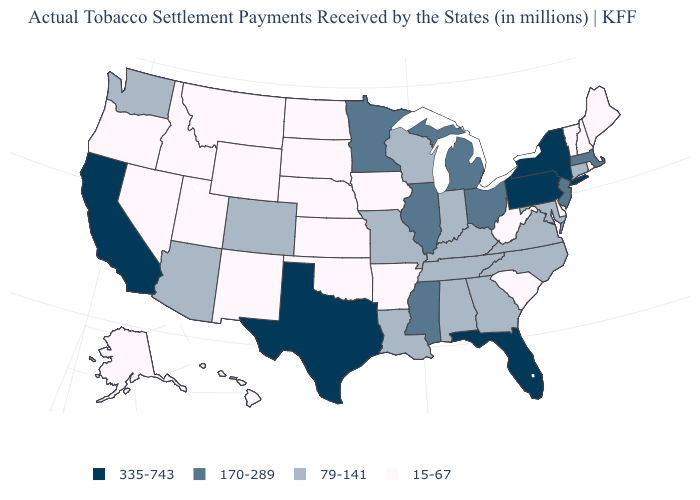Name the states that have a value in the range 79-141?
Quick response, please. Alabama, Arizona, Colorado, Connecticut, Georgia, Indiana, Kentucky, Louisiana, Maryland, Missouri, North Carolina, Tennessee, Virginia, Washington, Wisconsin. Does the first symbol in the legend represent the smallest category?
Answer briefly. No. What is the highest value in the West ?
Be succinct. 335-743. What is the value of Louisiana?
Short answer required. 79-141. Name the states that have a value in the range 15-67?
Be succinct. Alaska, Arkansas, Delaware, Hawaii, Idaho, Iowa, Kansas, Maine, Montana, Nebraska, Nevada, New Hampshire, New Mexico, North Dakota, Oklahoma, Oregon, Rhode Island, South Carolina, South Dakota, Utah, Vermont, West Virginia, Wyoming. Is the legend a continuous bar?
Quick response, please. No. Does Wyoming have the highest value in the USA?
Short answer required. No. What is the value of Pennsylvania?
Give a very brief answer. 335-743. What is the lowest value in states that border New Hampshire?
Answer briefly. 15-67. Among the states that border Oregon , which have the highest value?
Quick response, please. California. Name the states that have a value in the range 79-141?
Quick response, please. Alabama, Arizona, Colorado, Connecticut, Georgia, Indiana, Kentucky, Louisiana, Maryland, Missouri, North Carolina, Tennessee, Virginia, Washington, Wisconsin. What is the value of Hawaii?
Concise answer only. 15-67. Name the states that have a value in the range 15-67?
Write a very short answer. Alaska, Arkansas, Delaware, Hawaii, Idaho, Iowa, Kansas, Maine, Montana, Nebraska, Nevada, New Hampshire, New Mexico, North Dakota, Oklahoma, Oregon, Rhode Island, South Carolina, South Dakota, Utah, Vermont, West Virginia, Wyoming. 